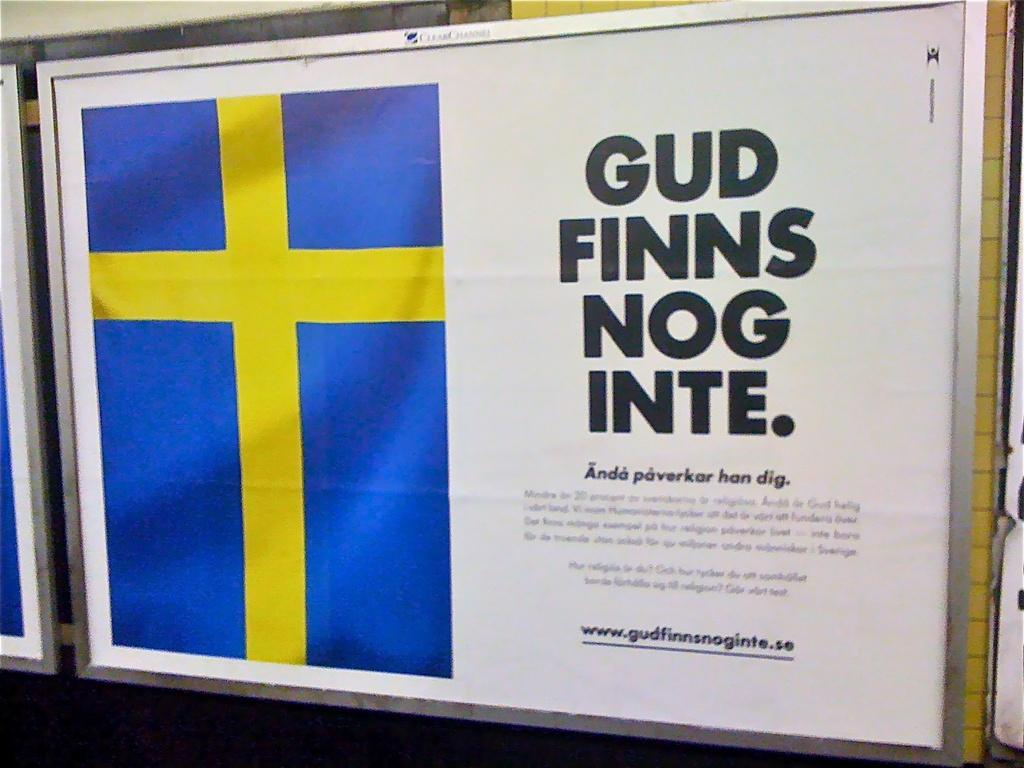<image>
Present a compact description of the photo's key features. A poster includes a blue rectangle with a yellow cross and the words Gud Finns Nog Inte. 